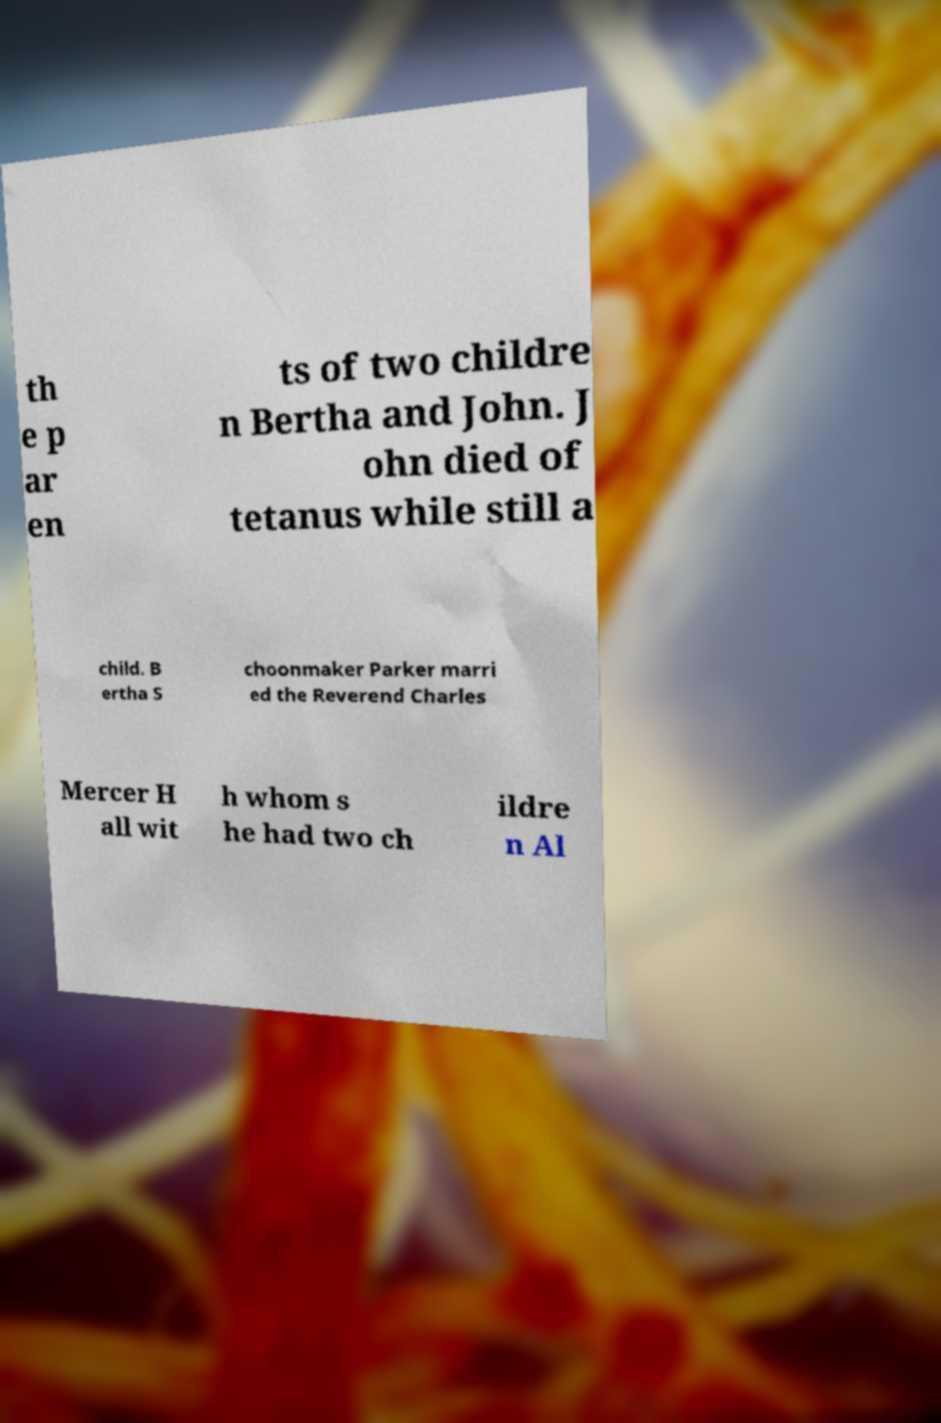What messages or text are displayed in this image? I need them in a readable, typed format. th e p ar en ts of two childre n Bertha and John. J ohn died of tetanus while still a child. B ertha S choonmaker Parker marri ed the Reverend Charles Mercer H all wit h whom s he had two ch ildre n Al 